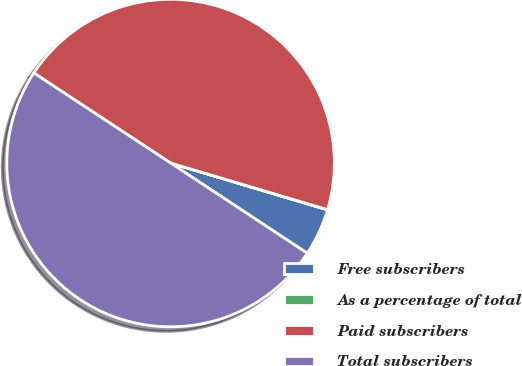Convert chart to OTSL. <chart><loc_0><loc_0><loc_500><loc_500><pie_chart><fcel>Free subscribers<fcel>As a percentage of total<fcel>Paid subscribers<fcel>Total subscribers<nl><fcel>4.67%<fcel>0.02%<fcel>45.33%<fcel>49.98%<nl></chart> 